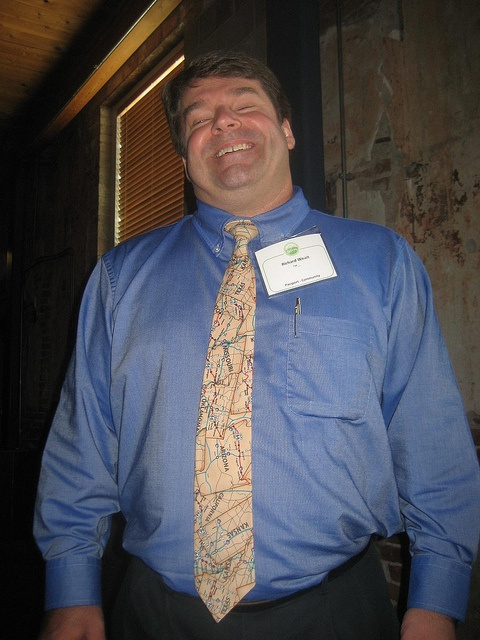Describe the objects in this image and their specific colors. I can see people in maroon, gray, and black tones and tie in maroon, tan, and darkgray tones in this image. 